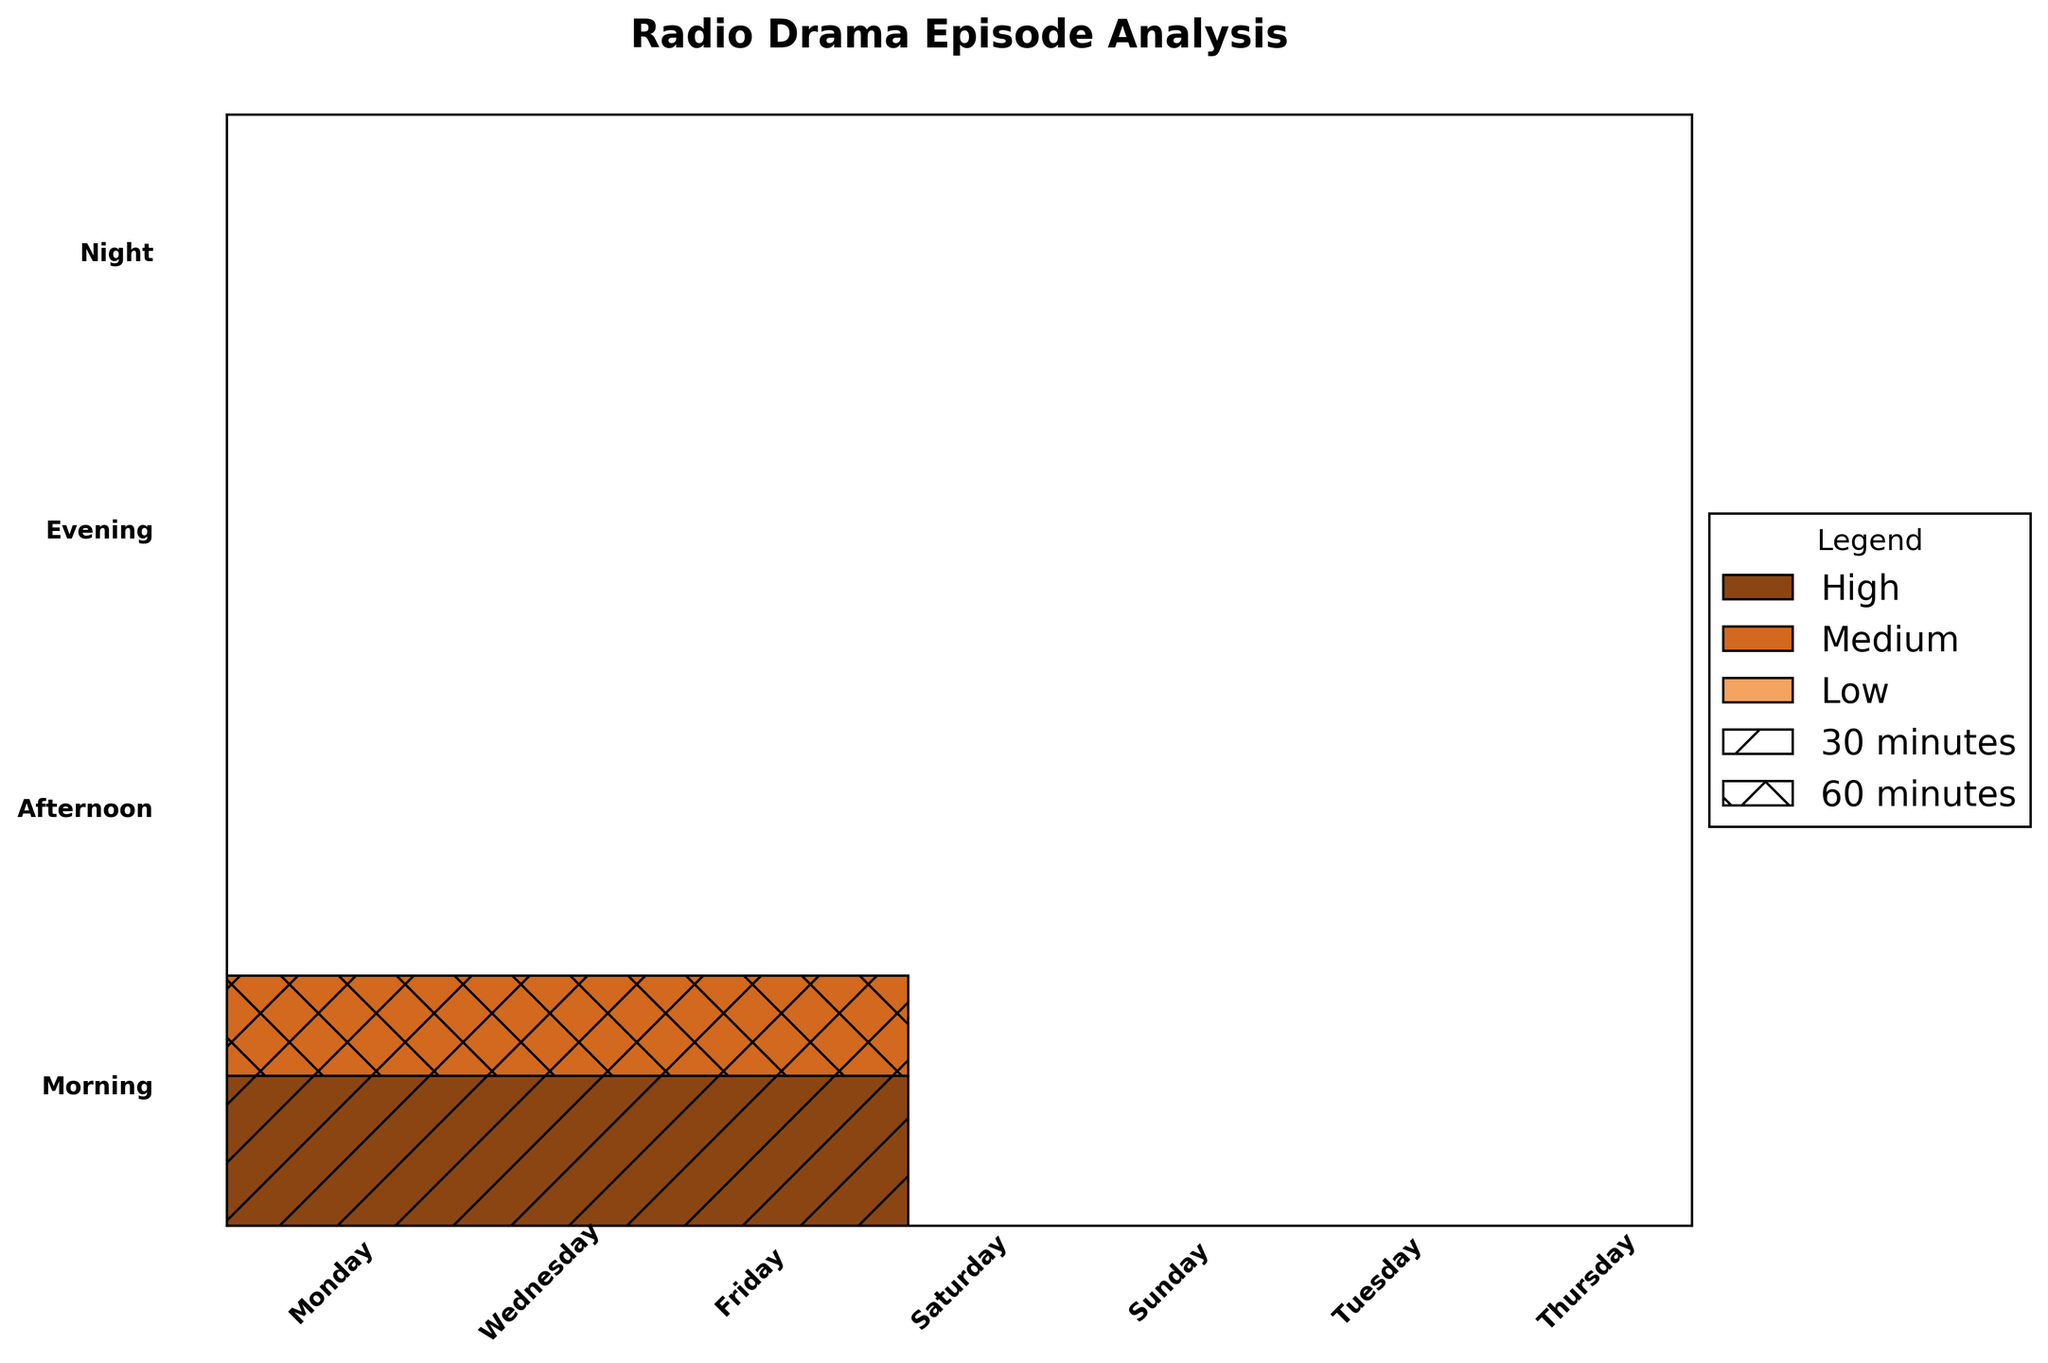What time slot has the highest number of high listener ratings on Sunday? Look for the tallest segment colored in dark brown (representing high listener ratings) within the Sunday column. The morning time slot has the highest number of high listener ratings on Sunday with 16.
Answer: Morning Which day of the week has the lowest number of listener counts for 30-minute episodes? Identify the shortest patterned segments with single stripes (representing 30-minute episodes) spread across all days. The lowest one is on Tuesday, with a count of 5.
Answer: Tuesday How do the morning time slots compare to the night time slots in terms of high listener ratings? Compare the total number of high listener rating segments colored in dark brown for morning and night time slots. Morning has 28 (12 on Monday + 16 on Sunday) and night has 34 (20 on Sunday + 14 on Saturday).
Answer: Night has higher On which day are there more medium listener ratings for afternoon 60-minute episodes? Check the medium listener rating segments with cross patterns (representing 60-minute episodes) in the afternoon slots across all days. The day with more medium ratings is Tuesday with a count of 11, compared to Wednesday's 10.
Answer: Tuesday What time slot has the lowest listener counts on Friday? Identify the smallest segment (regardless of color or pattern) within the Friday column. The smallest segment is 30 minutes long with a low listener rating, having a count of 6.
Answer: Evening Which day has the highest variation in both episode lengths and listener ratings in the evening time slot? Look for the day with evening segments showing different patterns (30 minutes and 60 minutes) and different colors (representing different ratings). Thursday shows a high variation with medium and high ratings, covering both 30 and 60 minutes episodes.
Answer: Thursday Are there any time slots with 60-minute episodes but no high listener ratings? Examine each time slot for cross-patterned segments that are not dark brown. The morning time slots on Monday and Sunday have 60-minute episodes with no high ratings, both having medium ratings instead.
Answer: Yes, Monday and Sunday mornings Which day shows a clearer preference for longer episodes in the night slot? Compare the size of the cross-patterned segments (60 minutes) and single-striped segments (30 minutes) in the night time slots. Sunday night clearly shows a higher preference for 60-minute episodes with a combined count of 30, compared to Saturday's 23.
Answer: Sunday What is the proportion of medium ratings in the morning time slot compared to high ratings in the night time slot? Calculate the total counts of medium ratings in the morning (8 Monday + 7 Sunday = 15) and high ratings in the night (20 Sunday + 14 Saturday = 34), then find the proportion (15/34 ≈ 0.44).
Answer: Approximately 0.44 